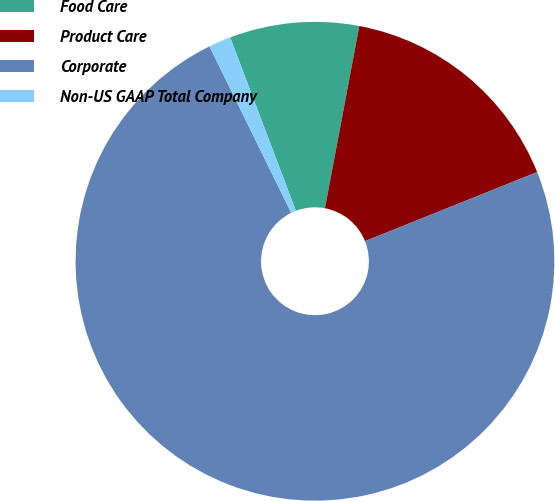<chart> <loc_0><loc_0><loc_500><loc_500><pie_chart><fcel>Food Care<fcel>Product Care<fcel>Corporate<fcel>Non-US GAAP Total Company<nl><fcel>8.73%<fcel>15.96%<fcel>73.81%<fcel>1.5%<nl></chart> 